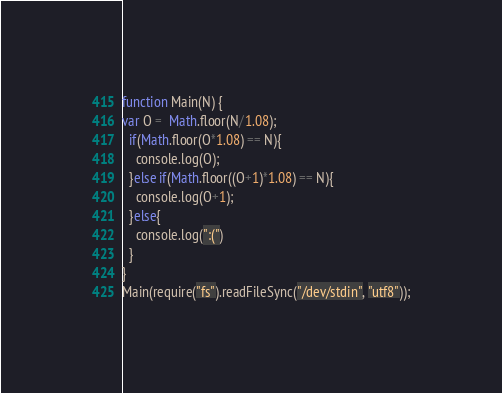<code> <loc_0><loc_0><loc_500><loc_500><_JavaScript_>function Main(N) {
var O =  Math.floor(N/1.08);
  if(Math.floor(O*1.08) == N){
    console.log(O);
  }else if(Math.floor((O+1)*1.08) == N){
    console.log(O+1);
  }else{
    console.log(":(")
  }
}
Main(require("fs").readFileSync("/dev/stdin", "utf8"));</code> 